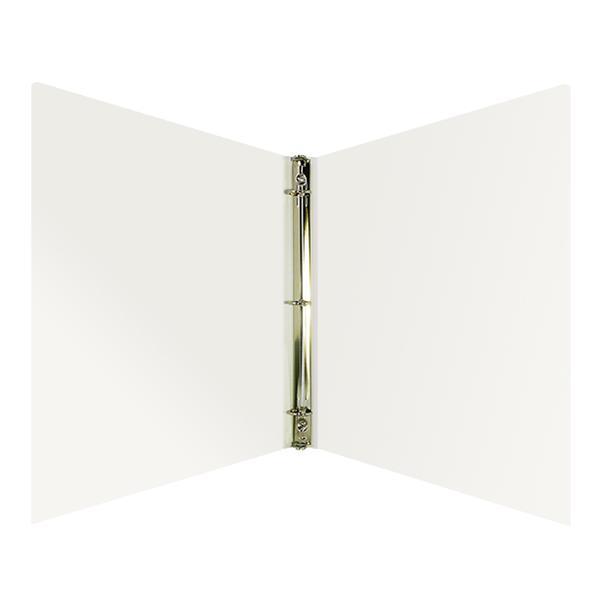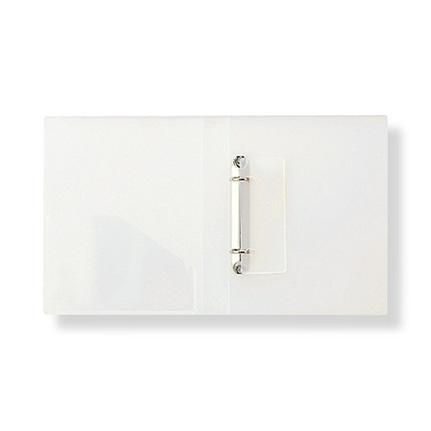The first image is the image on the left, the second image is the image on the right. Evaluate the accuracy of this statement regarding the images: "There are no more than two binders shown.". Is it true? Answer yes or no. Yes. The first image is the image on the left, the second image is the image on the right. For the images displayed, is the sentence "One image includes at least one closed, upright binder next to an open upright binder, and the combined images contain at least some non-white binders." factually correct? Answer yes or no. No. 